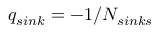Convert formula to latex. <formula><loc_0><loc_0><loc_500><loc_500>q _ { \sin k } = - 1 / N _ { \sin k s }</formula> 